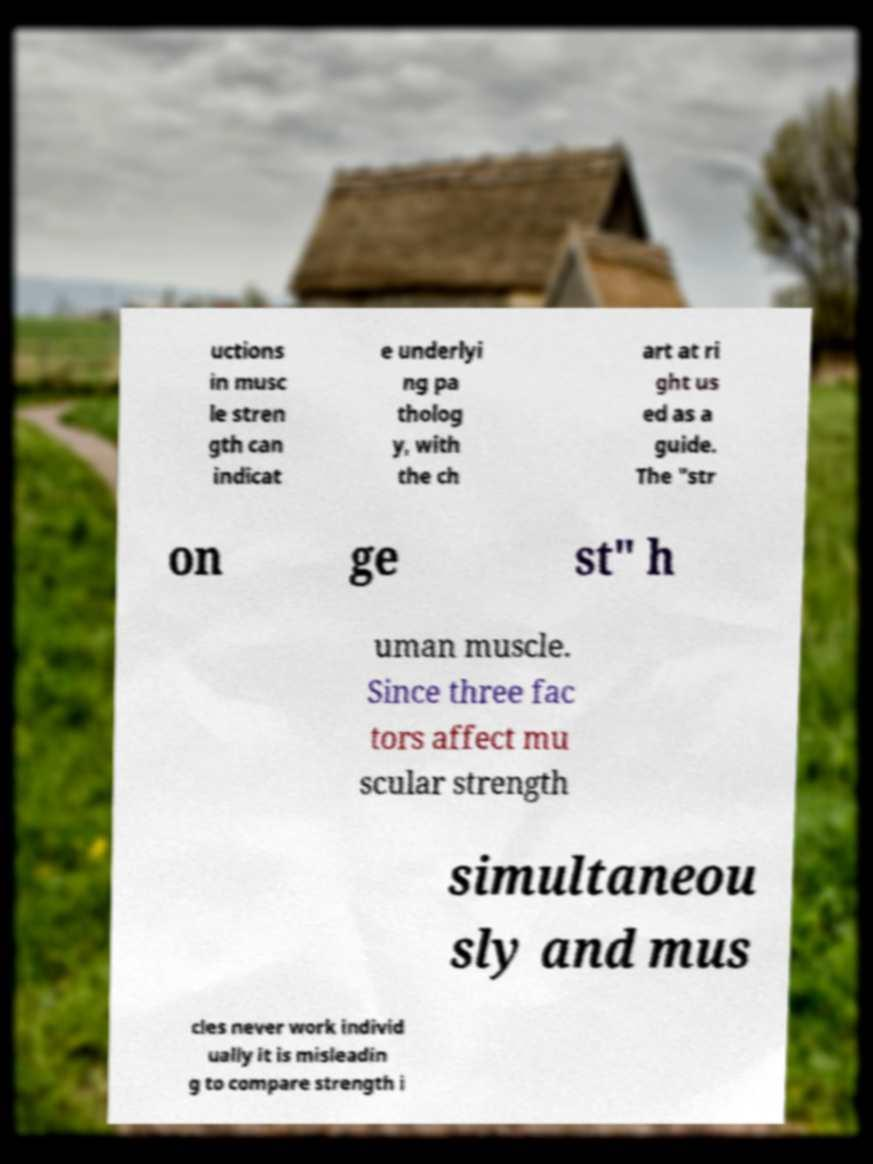Can you read and provide the text displayed in the image?This photo seems to have some interesting text. Can you extract and type it out for me? uctions in musc le stren gth can indicat e underlyi ng pa tholog y, with the ch art at ri ght us ed as a guide. The "str on ge st" h uman muscle. Since three fac tors affect mu scular strength simultaneou sly and mus cles never work individ ually it is misleadin g to compare strength i 